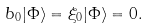Convert formula to latex. <formula><loc_0><loc_0><loc_500><loc_500>b _ { 0 } | \Phi \rangle = \xi _ { 0 } | \Phi \rangle = 0 .</formula> 